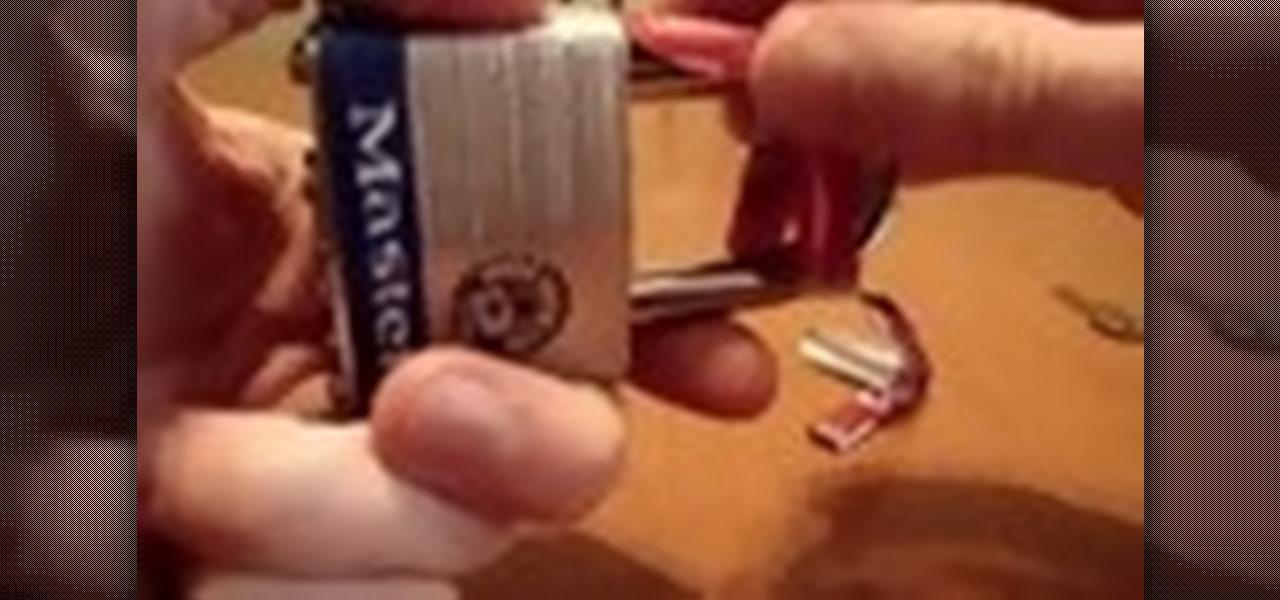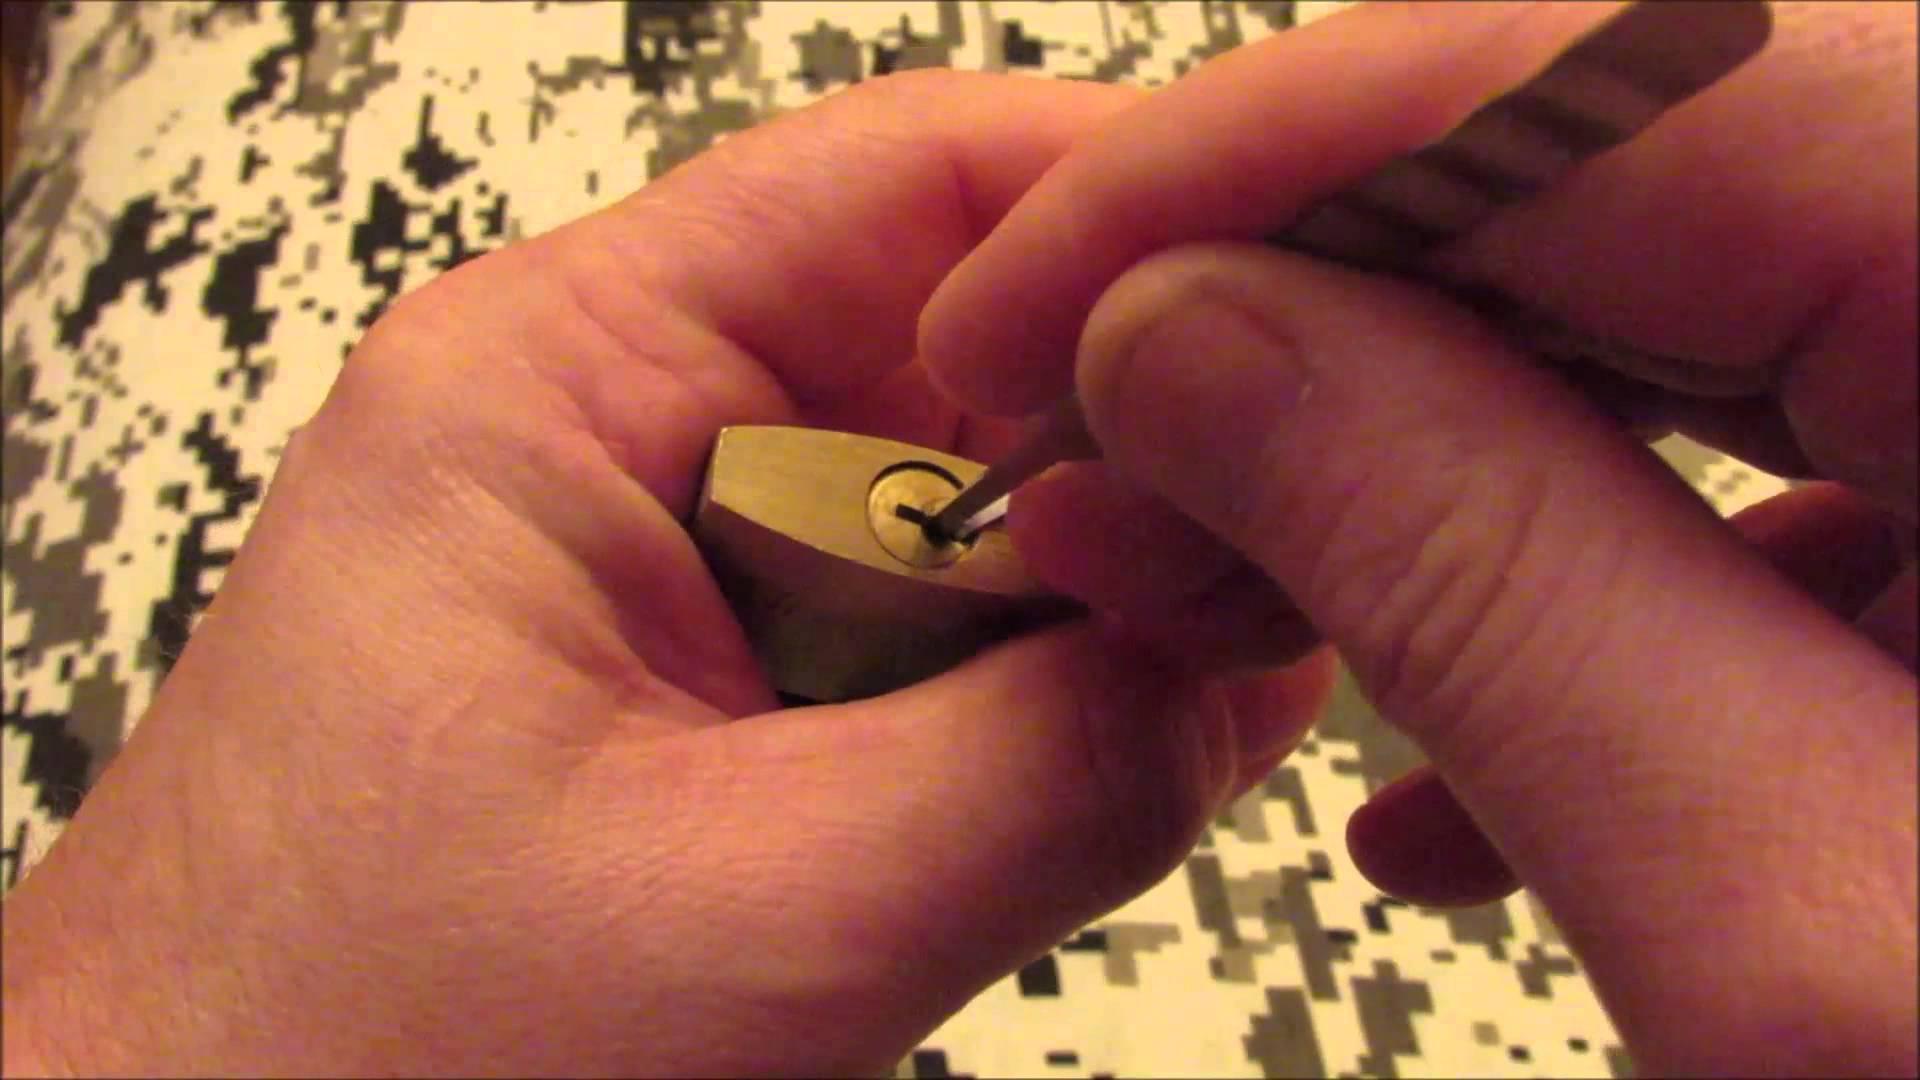The first image is the image on the left, the second image is the image on the right. For the images shown, is this caption "The right image shows a hand inserting something pointed into the keyhole." true? Answer yes or no. Yes. 